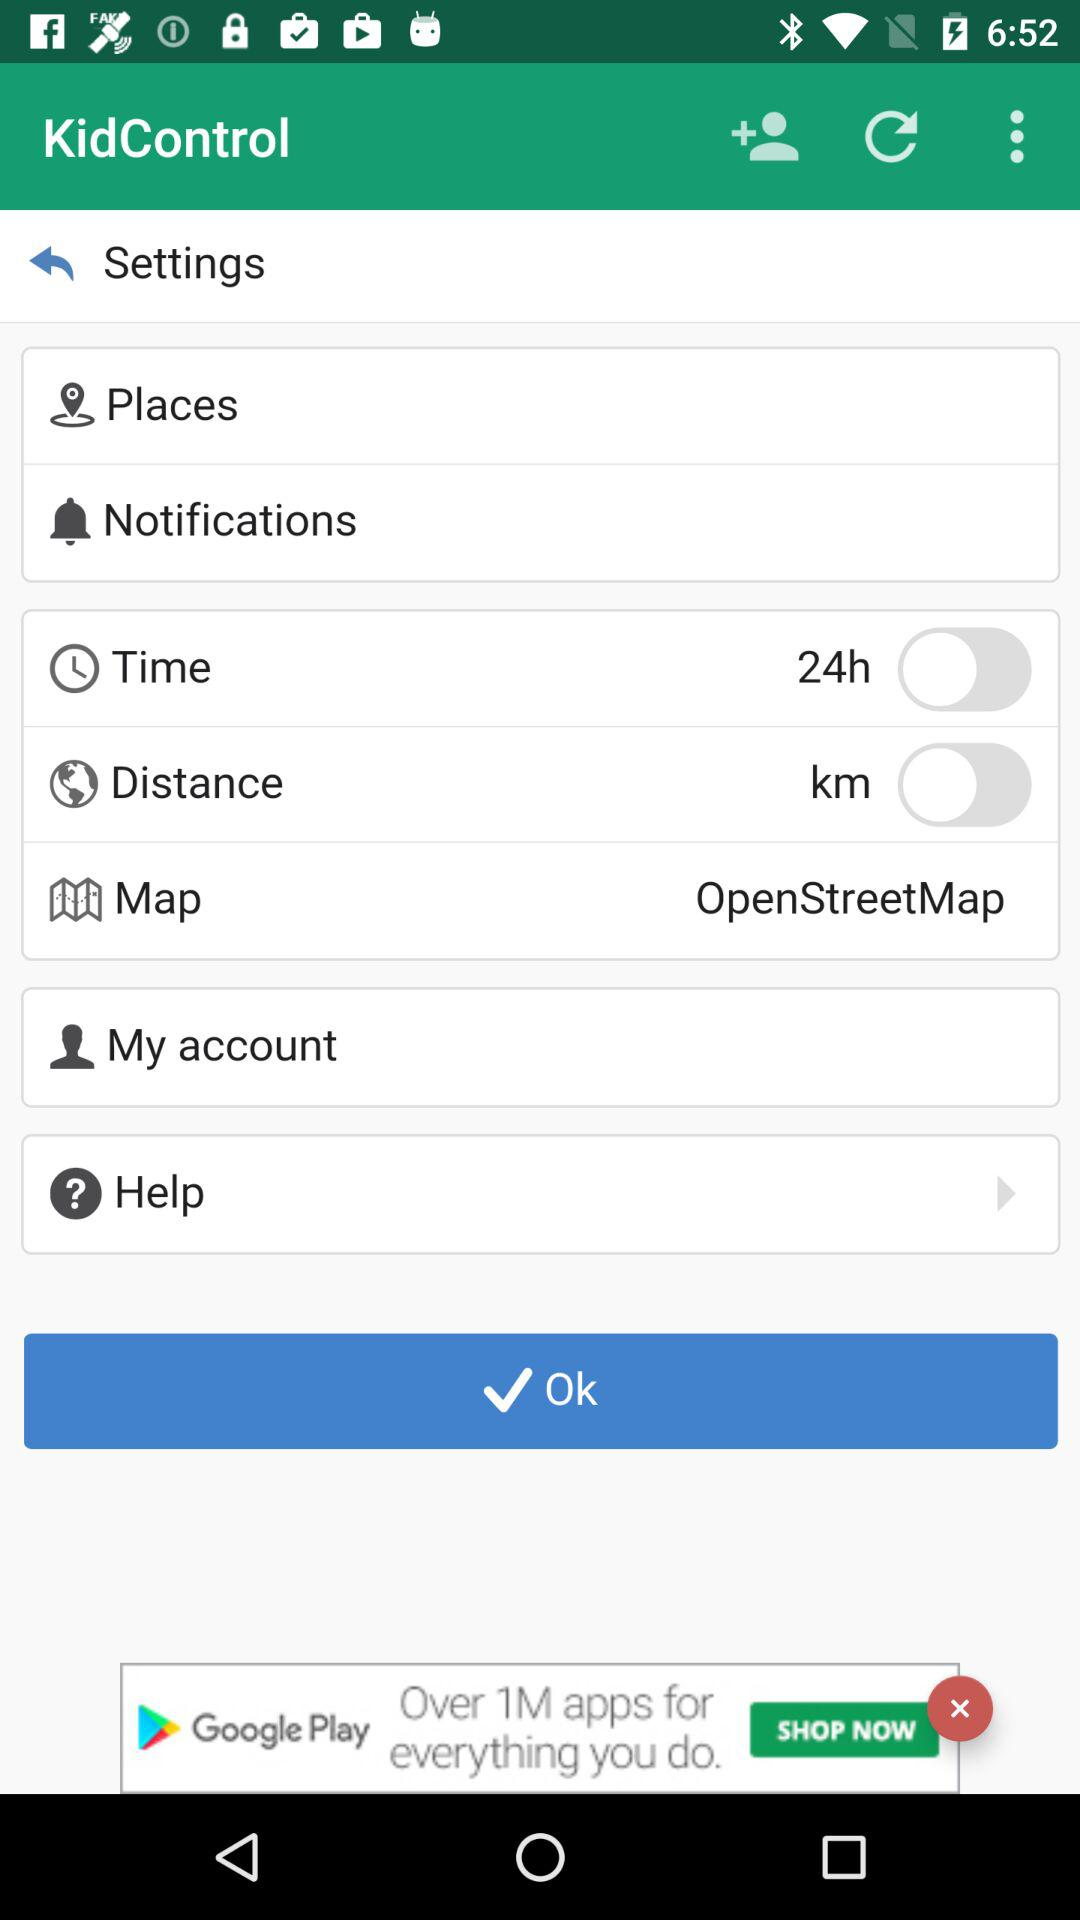What is the unit of distance? The unit of distance is "km". 